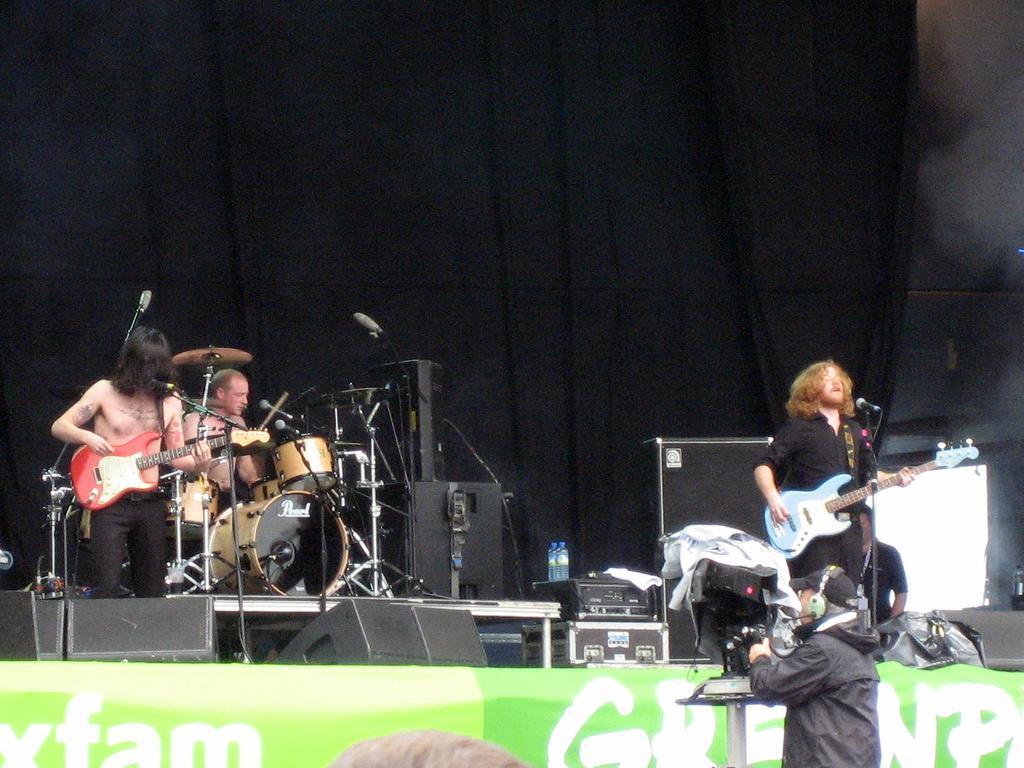Describe this image in one or two sentences. In this image we can see few people on the stage. On the right side of the we can see a man holding a guitar and playing it. In the background of the image we can see a man playing electronic drums. This man is recording the show through video camera. 